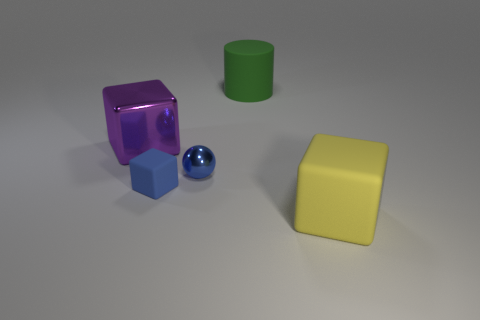Add 2 metallic things. How many objects exist? 7 Subtract all blocks. How many objects are left? 2 Subtract all tiny metal spheres. Subtract all rubber things. How many objects are left? 1 Add 5 green things. How many green things are left? 6 Add 5 cyan matte balls. How many cyan matte balls exist? 5 Subtract 0 gray cylinders. How many objects are left? 5 